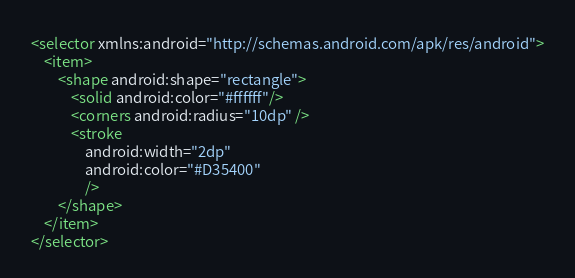<code> <loc_0><loc_0><loc_500><loc_500><_XML_><selector xmlns:android="http://schemas.android.com/apk/res/android">
    <item>
        <shape android:shape="rectangle">
            <solid android:color="#ffffff"/>
            <corners android:radius="10dp" />
            <stroke
                android:width="2dp"
                android:color="#D35400"
                />
        </shape>
    </item>
</selector></code> 